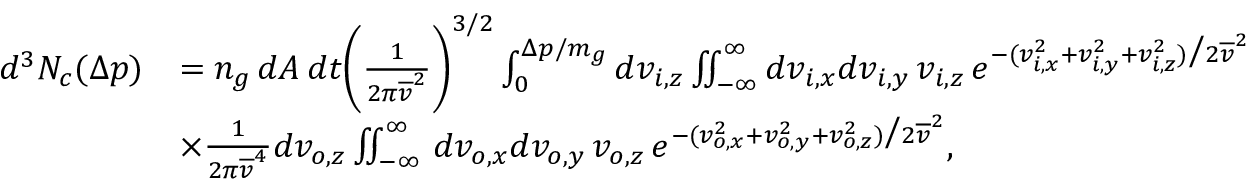Convert formula to latex. <formula><loc_0><loc_0><loc_500><loc_500>\begin{array} { r l } { d ^ { 3 } N _ { c } ( \Delta p ) } & { = n _ { g } \, d A \, d t \left ( \frac { 1 } { 2 \pi \overline { v } ^ { 2 } } \right ) ^ { 3 / 2 } \int _ { 0 } ^ { \Delta p / m _ { g } } d v _ { i , z } \iint _ { - \infty } ^ { \infty } d v _ { i , x } d v _ { i , y } \, v _ { i , z } \, e ^ { - ( v _ { i , x } ^ { 2 } + v _ { i , y } ^ { 2 } + v _ { i , z } ^ { 2 } ) \Big / 2 \overline { v } ^ { 2 } } } \\ & { \times \frac { 1 } { 2 \pi \overline { v } ^ { 4 } } d v _ { o , z } \iint _ { - \infty } ^ { \infty } \, d v _ { o , x } d v _ { o , y } \, v _ { o , z } \, e ^ { - ( v _ { o , x } ^ { 2 } + v _ { o , y } ^ { 2 } + v _ { o , z } ^ { 2 } ) \Big / 2 \overline { v } ^ { 2 } } , } \end{array}</formula> 